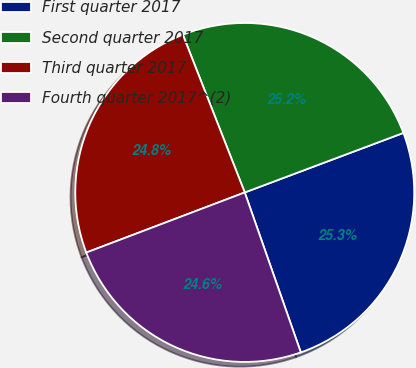Convert chart to OTSL. <chart><loc_0><loc_0><loc_500><loc_500><pie_chart><fcel>First quarter 2017<fcel>Second quarter 2017<fcel>Third quarter 2017<fcel>Fourth quarter 2017^(2)<nl><fcel>25.35%<fcel>25.24%<fcel>24.82%<fcel>24.6%<nl></chart> 